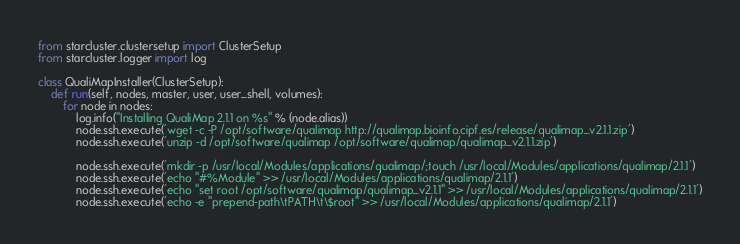Convert code to text. <code><loc_0><loc_0><loc_500><loc_500><_Python_>from starcluster.clustersetup import ClusterSetup
from starcluster.logger import log

class QualiMapInstaller(ClusterSetup):
	def run(self, nodes, master, user, user_shell, volumes):
		for node in nodes:
			log.info("Installing QualiMap 2.1.1 on %s" % (node.alias))
			node.ssh.execute('wget -c -P /opt/software/qualimap http://qualimap.bioinfo.cipf.es/release/qualimap_v2.1.1.zip')
			node.ssh.execute('unzip -d /opt/software/qualimap /opt/software/qualimap/qualimap_v2.1.1.zip')
			
			node.ssh.execute('mkdir -p /usr/local/Modules/applications/qualimap/;touch /usr/local/Modules/applications/qualimap/2.1.1')
			node.ssh.execute('echo "#%Module" >> /usr/local/Modules/applications/qualimap/2.1.1')
			node.ssh.execute('echo "set root /opt/software/qualimap/qualimap_v2.1.1" >> /usr/local/Modules/applications/qualimap/2.1.1')
			node.ssh.execute('echo -e "prepend-path\tPATH\t\$root" >> /usr/local/Modules/applications/qualimap/2.1.1')</code> 